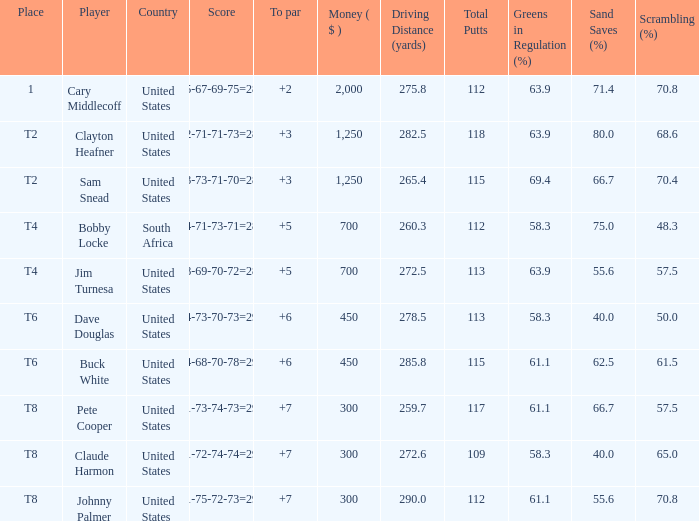What is Claude Harmon's Place? T8. Could you help me parse every detail presented in this table? {'header': ['Place', 'Player', 'Country', 'Score', 'To par', 'Money ( $ )', 'Driving Distance (yards)', 'Total Putts', 'Greens in Regulation (%)', 'Sand Saves (%)', 'Scrambling (%)'], 'rows': [['1', 'Cary Middlecoff', 'United States', '75-67-69-75=286', '+2', '2,000', '275.8', '112', '63.9', '71.4', '70.8'], ['T2', 'Clayton Heafner', 'United States', '72-71-71-73=287', '+3', '1,250', '282.5', '118', '63.9', '80.0', '68.6'], ['T2', 'Sam Snead', 'United States', '73-73-71-70=287', '+3', '1,250', '265.4', '115', '69.4', '66.7', '70.4'], ['T4', 'Bobby Locke', 'South Africa', '74-71-73-71=289', '+5', '700', '260.3', '112', '58.3', '75.0', '48.3'], ['T4', 'Jim Turnesa', 'United States', '78-69-70-72=289', '+5', '700', '272.5', '113', '63.9', '55.6', '57.5'], ['T6', 'Dave Douglas', 'United States', '74-73-70-73=290', '+6', '450', '278.5', '113', '58.3', '40.0', '50.0'], ['T6', 'Buck White', 'United States', '74-68-70-78=290', '+6', '450', '285.8', '115', '61.1', '62.5', '61.5'], ['T8', 'Pete Cooper', 'United States', '71-73-74-73=291', '+7', '300', '259.7', '117', '61.1', '66.7', '57.5'], ['T8', 'Claude Harmon', 'United States', '71-72-74-74=291', '+7', '300', '272.6', '109', '58.3', '40.0', '65.0'], ['T8', 'Johnny Palmer', 'United States', '71-75-72-73=291', '+7', '300', '290.0', '112', '61.1', '55.6', '70.8']]} 